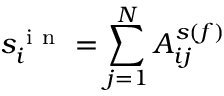Convert formula to latex. <formula><loc_0><loc_0><loc_500><loc_500>s _ { i } ^ { i n } = \sum _ { j = 1 } ^ { N } A _ { i j } ^ { s ( f ) }</formula> 